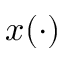Convert formula to latex. <formula><loc_0><loc_0><loc_500><loc_500>x ( \cdot )</formula> 